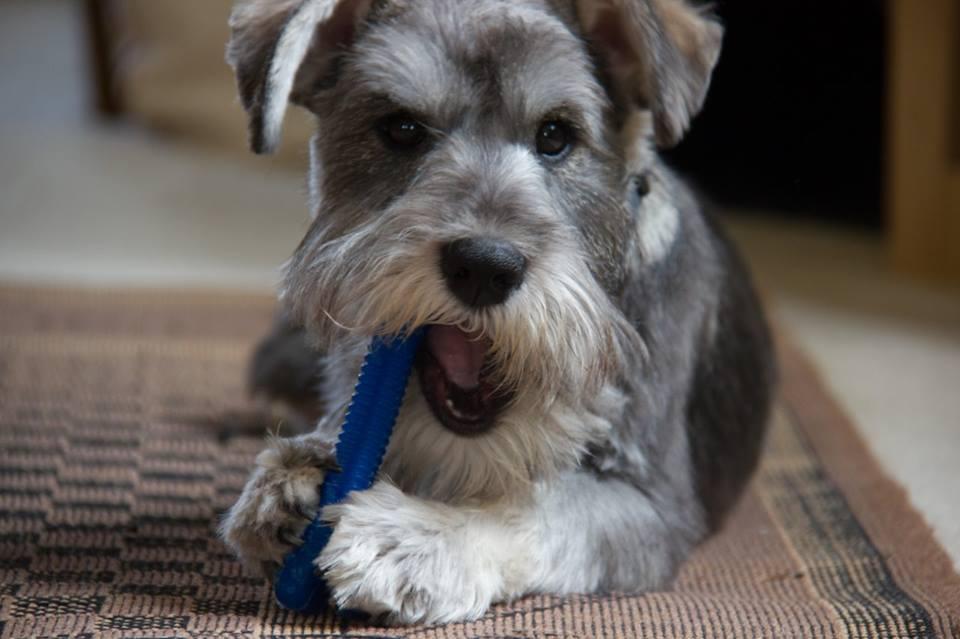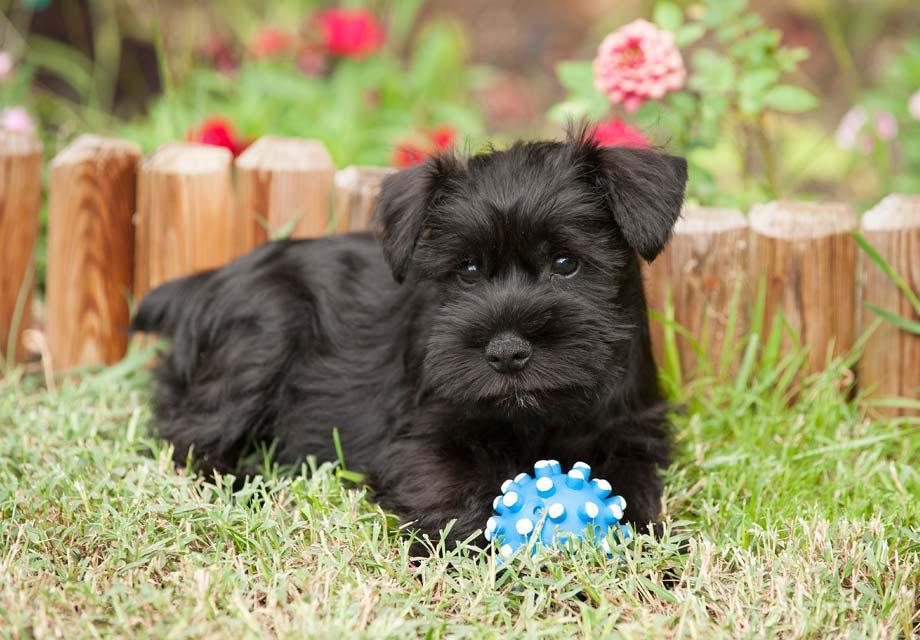The first image is the image on the left, the second image is the image on the right. For the images shown, is this caption "The animal on the right is lying on a green colored surface." true? Answer yes or no. Yes. The first image is the image on the left, the second image is the image on the right. Evaluate the accuracy of this statement regarding the images: "There is a colorful dog toy in the image on the right". Is it true? Answer yes or no. Yes. The first image is the image on the left, the second image is the image on the right. Given the left and right images, does the statement "There are two dogs inside." hold true? Answer yes or no. No. The first image is the image on the left, the second image is the image on the right. Evaluate the accuracy of this statement regarding the images: "An image shows a dog with its mouth on some type of chew bone.". Is it true? Answer yes or no. Yes. 